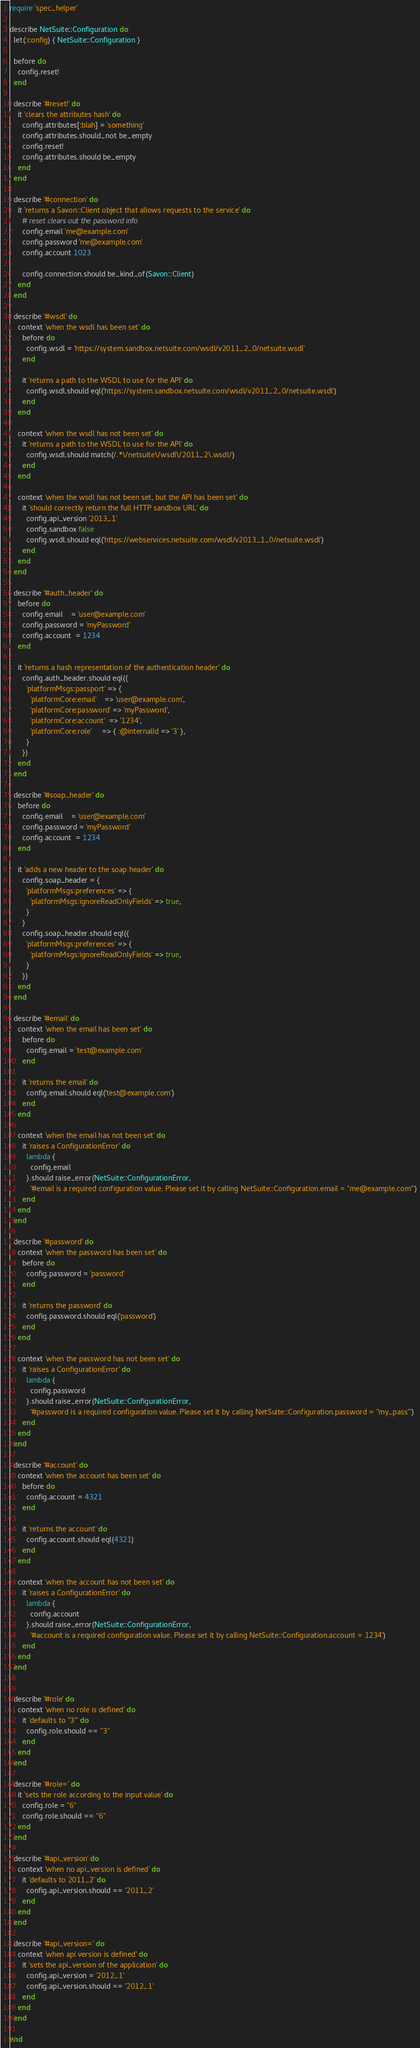<code> <loc_0><loc_0><loc_500><loc_500><_Ruby_>require 'spec_helper'

describe NetSuite::Configuration do
  let(:config) { NetSuite::Configuration }

  before do
    config.reset!
  end

  describe '#reset!' do
    it 'clears the attributes hash' do
      config.attributes[:blah] = 'something'
      config.attributes.should_not be_empty
      config.reset!
      config.attributes.should be_empty
    end
  end

  describe '#connection' do
    it 'returns a Savon::Client object that allows requests to the service' do
      # reset clears out the password info
      config.email 'me@example.com'
      config.password 'me@example.com'
      config.account 1023

      config.connection.should be_kind_of(Savon::Client)
    end
  end

  describe '#wsdl' do
    context 'when the wsdl has been set' do
      before do
        config.wsdl = 'https://system.sandbox.netsuite.com/wsdl/v2011_2_0/netsuite.wsdl'
      end

      it 'returns a path to the WSDL to use for the API' do
        config.wsdl.should eql('https://system.sandbox.netsuite.com/wsdl/v2011_2_0/netsuite.wsdl')
      end
    end

    context 'when the wsdl has not been set' do
      it 'returns a path to the WSDL to use for the API' do
        config.wsdl.should match(/.*\/netsuite\/wsdl\/2011_2\.wsdl/)
      end
    end

    context 'when the wsdl has not been set, but the API has been set' do
      it 'should correctly return the full HTTP sandbox URL' do
        config.api_version '2013_1'
        config.sandbox false
        config.wsdl.should eql('https://webservices.netsuite.com/wsdl/v2013_1_0/netsuite.wsdl')
      end
    end
  end

  describe '#auth_header' do
    before do
      config.email    = 'user@example.com'
      config.password = 'myPassword'
      config.account  = 1234
    end

    it 'returns a hash representation of the authentication header' do
      config.auth_header.should eql({
        'platformMsgs:passport' => {
          'platformCore:email'    => 'user@example.com',
          'platformCore:password' => 'myPassword',
          'platformCore:account'  => '1234',
          'platformCore:role'     => { :@internalId => '3' },
        }
      })
    end
  end

  describe '#soap_header' do
    before do
      config.email    = 'user@example.com'
      config.password = 'myPassword'
      config.account  = 1234
    end

    it 'adds a new header to the soap header' do
      config.soap_header = {
        'platformMsgs:preferences' => {
          'platformMsgs:ignoreReadOnlyFields' => true,
        }
      }
      config.soap_header.should eql({
        'platformMsgs:preferences' => {
          'platformMsgs:ignoreReadOnlyFields' => true,
        }
      })
    end
  end

  describe '#email' do
    context 'when the email has been set' do
      before do
        config.email = 'test@example.com'
      end

      it 'returns the email' do
        config.email.should eql('test@example.com')
      end
    end

    context 'when the email has not been set' do
      it 'raises a ConfigurationError' do
        lambda {
          config.email
        }.should raise_error(NetSuite::ConfigurationError,
          '#email is a required configuration value. Please set it by calling NetSuite::Configuration.email = "me@example.com"')
      end
    end
  end

  describe '#password' do
    context 'when the password has been set' do
      before do
        config.password = 'password'
      end

      it 'returns the password' do
        config.password.should eql('password')
      end
    end

    context 'when the password has not been set' do
      it 'raises a ConfigurationError' do
        lambda {
          config.password
        }.should raise_error(NetSuite::ConfigurationError,
          '#password is a required configuration value. Please set it by calling NetSuite::Configuration.password = "my_pass"')
      end
    end
  end

  describe '#account' do
    context 'when the account has been set' do
      before do
        config.account = 4321
      end

      it 'returns the account' do
        config.account.should eql(4321)
      end
    end

    context 'when the account has not been set' do
      it 'raises a ConfigurationError' do
        lambda {
          config.account
        }.should raise_error(NetSuite::ConfigurationError,
          '#account is a required configuration value. Please set it by calling NetSuite::Configuration.account = 1234')
      end
    end
  end


  describe '#role' do
    context 'when no role is defined' do
      it 'defaults to "3"' do
        config.role.should == "3"
      end
    end
  end

  describe '#role=' do
    it 'sets the role according to the input value' do
      config.role = "6"
      config.role.should == "6"
    end
  end

  describe '#api_version' do
    context 'when no api_version is defined' do
      it 'defaults to 2011_2' do
        config.api_version.should == '2011_2'
      end
    end
  end

  describe '#api_version=' do
    context 'when api version is defined' do
      it 'sets the api_version of the application' do
        config.api_version = '2012_1'
        config.api_version.should == '2012_1'
      end
    end
  end

end
</code> 